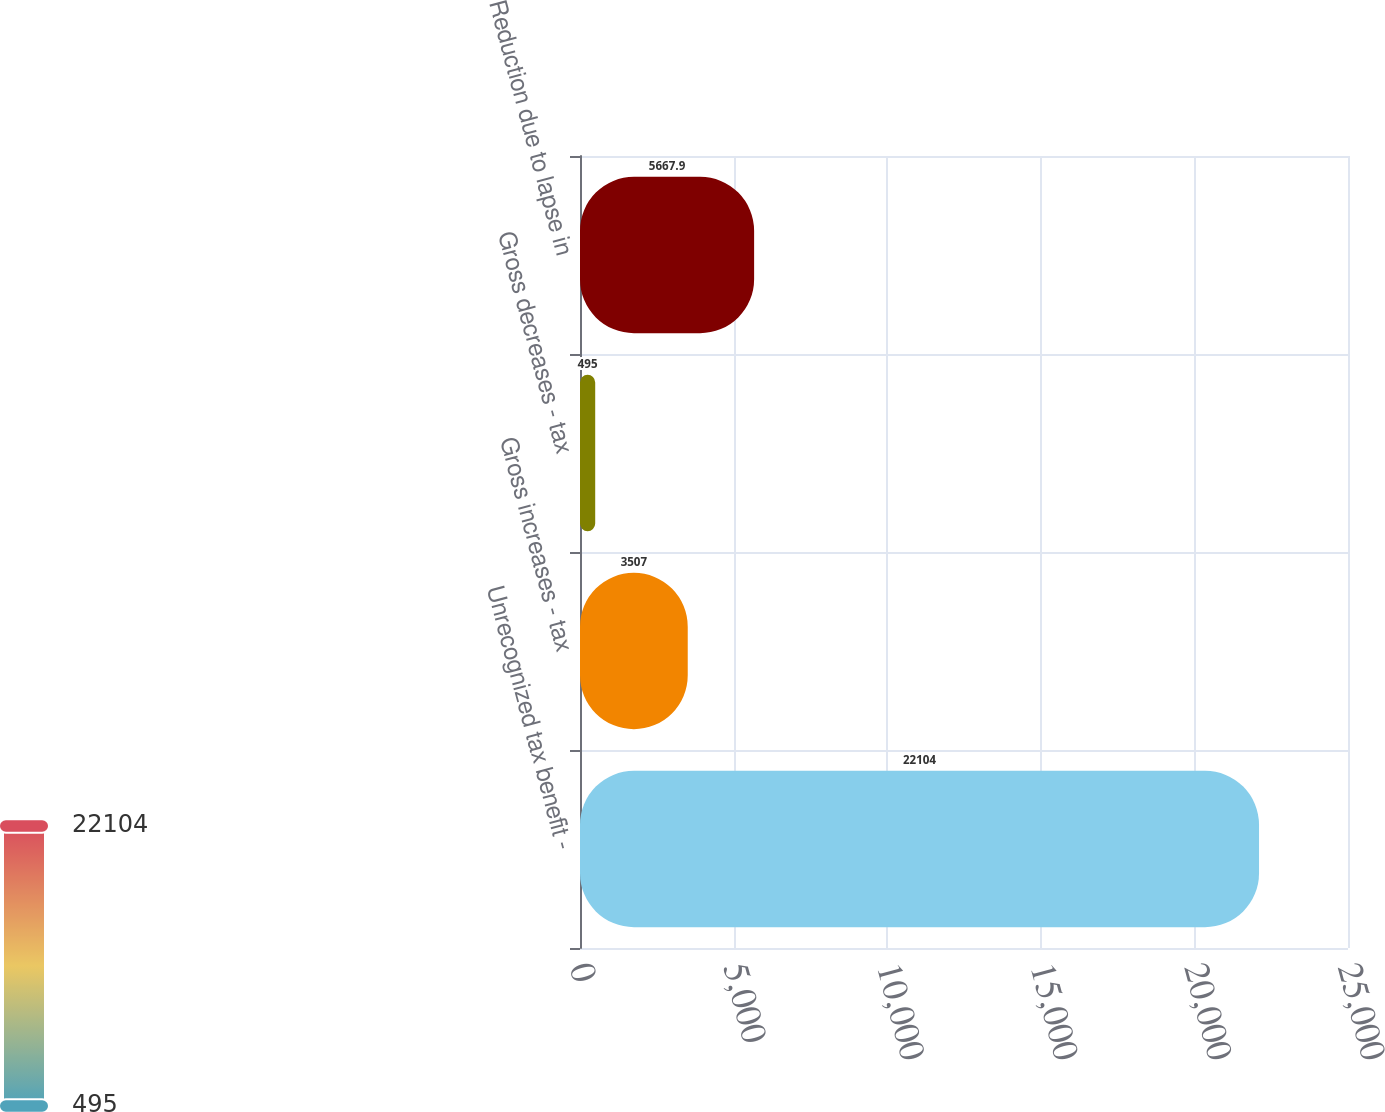Convert chart to OTSL. <chart><loc_0><loc_0><loc_500><loc_500><bar_chart><fcel>Unrecognized tax benefit -<fcel>Gross increases - tax<fcel>Gross decreases - tax<fcel>Reduction due to lapse in<nl><fcel>22104<fcel>3507<fcel>495<fcel>5667.9<nl></chart> 